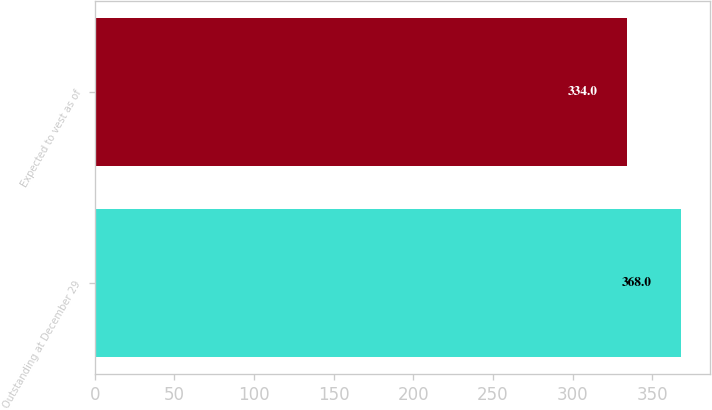Convert chart to OTSL. <chart><loc_0><loc_0><loc_500><loc_500><bar_chart><fcel>Outstanding at December 29<fcel>Expected to vest as of<nl><fcel>368<fcel>334<nl></chart> 